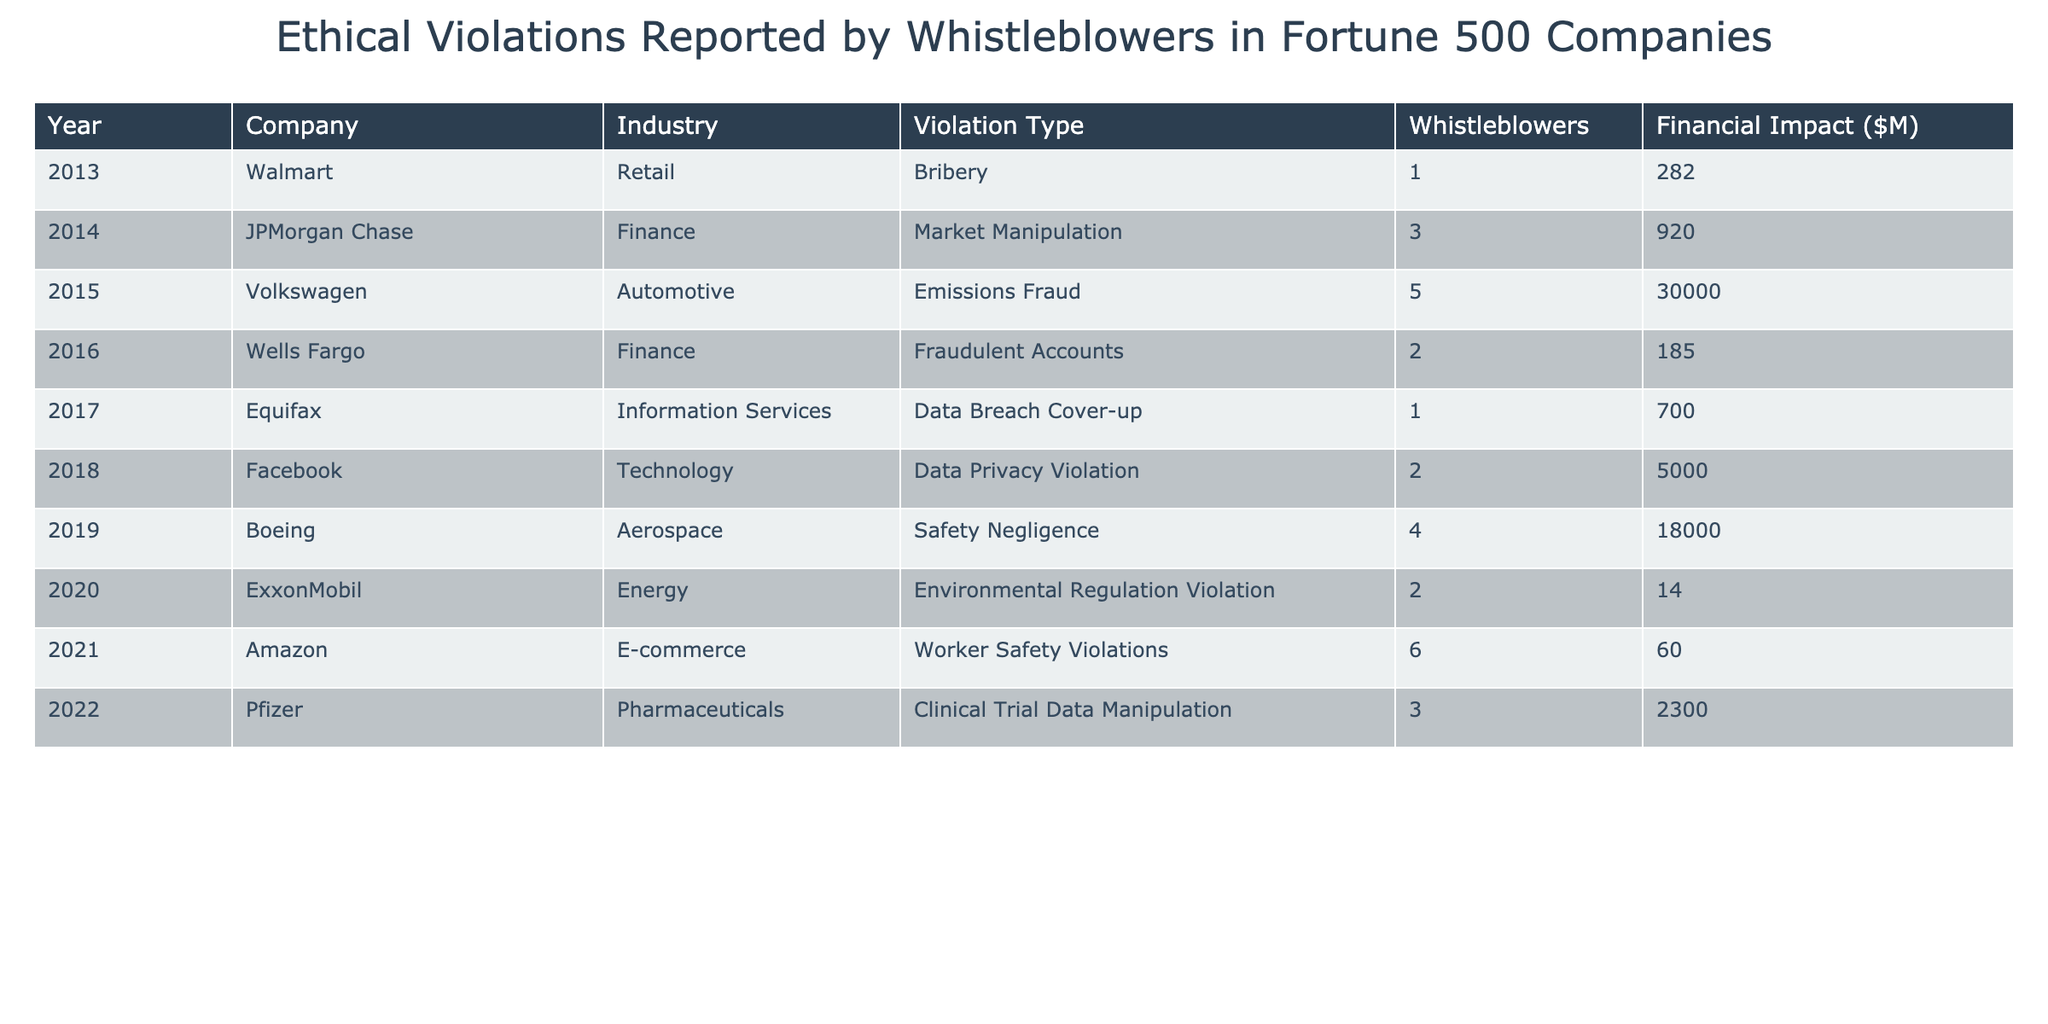What was the total financial impact of violations reported in 2015? The financial impacts reported in 2015 include only Volkswagen with an impact of $30,000 million. Since it's the only entry for that year, the total is simply $30,000 million.
Answer: $30,000 million Which company reported the least financial impact for their violation, and what was the amount? The company with the least financial impact is ExxonMobil in 2020, which reported a financial impact of $14 million.
Answer: ExxonMobil; $14 million How many companies had whistleblowers reporting violations in the technology industry? The only company in the technology industry that had whistleblowers reporting violations was Facebook in 2018, with 2 reported whistleblowers. So, the count is one.
Answer: 1 Which year had the highest number of whistleblowers reported, and how many were there? The year with the highest number of whistleblowers is 2021, with 6 reported from Amazon.
Answer: 2021; 6 What is the average financial impact of violations across all reported years? The total financial impact is $30,000 + $920 + $30000 + $185 + $700 + $5000 + $18000 + $14 + $60 + $2300 = $59709 million, across 10 entries. Dividing gives an average of $5970.9 million.
Answer: $5970.9 million Did any company report multiple types of violations in the table? No, each company reported only one type of violation in the data provided.
Answer: No What is the ratio of whistleblowers in the finance industry to the total number of whistleblowers reported? In the finance industry, there were 3 whistleblowers in JPMorgan Chase and 2 in Wells Fargo, giving a total of 5. The total number of whistleblowers across all companies is 1 + 3 + 5 + 2 + 1 + 2 + 4 + 2 + 6 + 3 = 29. The ratio is 5:29.
Answer: 5:29 How much financial impact was reported from healthcare-related violations? The only healthcare-related violation in the table is Pfizer's in 2022, which reported a financial impact of $2,300 million.
Answer: $2,300 million What proportion of total financial impact is attributed to the automotive industry violations? The automotive industry has Volkswagen's $30,000 million financial impact. The total impact is $59,709 million. The proportion is ($30,000 / $59,709) * 100 = approximately 50.2%.
Answer: ~50.2% In 2019, how many whistleblowers reported violations compared to 2018? In 2019, Boeing had 4 whistleblowers, while in 2018, Facebook had 2. The comparison gives 4 to 2, so 4 reported in 2019.
Answer: 4 (2019); 2 (2018) 